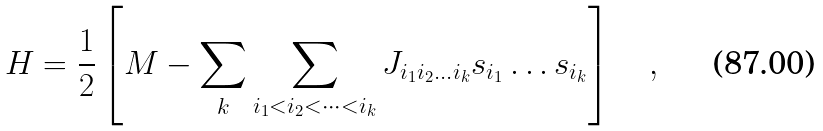Convert formula to latex. <formula><loc_0><loc_0><loc_500><loc_500>H = \frac { 1 } { 2 } \left [ M - \sum _ { k } \sum _ { i _ { 1 } < i _ { 2 } < \dots < i _ { k } } J _ { i _ { 1 } i _ { 2 } \dots i _ { k } } s _ { i _ { 1 } } \dots s _ { i _ { k } } \right ] \quad ,</formula> 